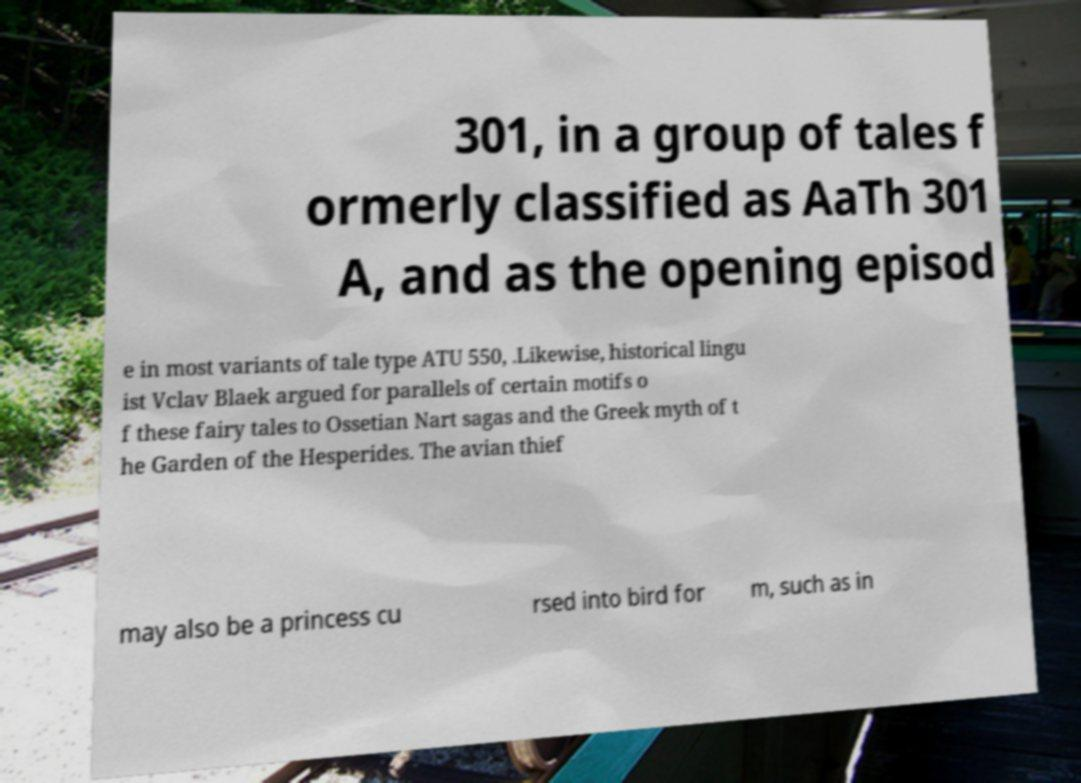Can you accurately transcribe the text from the provided image for me? 301, in a group of tales f ormerly classified as AaTh 301 A, and as the opening episod e in most variants of tale type ATU 550, .Likewise, historical lingu ist Vclav Blaek argued for parallels of certain motifs o f these fairy tales to Ossetian Nart sagas and the Greek myth of t he Garden of the Hesperides. The avian thief may also be a princess cu rsed into bird for m, such as in 